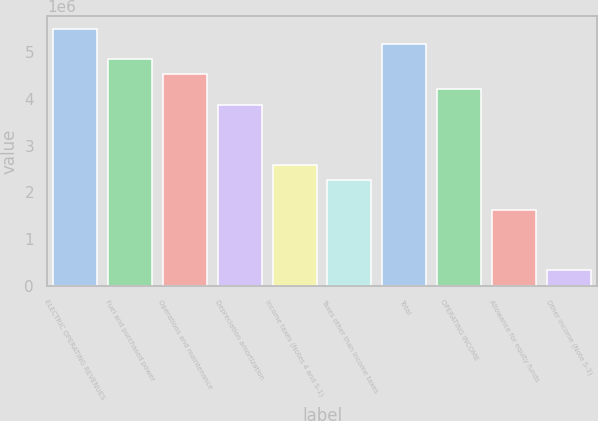<chart> <loc_0><loc_0><loc_500><loc_500><bar_chart><fcel>ELECTRIC OPERATING REVENUES<fcel>Fuel and purchased power<fcel>Operations and maintenance<fcel>Depreciation amortization<fcel>Income taxes (Notes 4 and S-1)<fcel>Taxes other than income taxes<fcel>Total<fcel>OPERATING INCOME<fcel>Allowance for equity funds<fcel>Other income (Note S-3)<nl><fcel>5.50008e+06<fcel>4.85355e+06<fcel>4.53029e+06<fcel>3.88377e+06<fcel>2.59072e+06<fcel>2.26745e+06<fcel>5.17682e+06<fcel>4.20703e+06<fcel>1.62093e+06<fcel>327878<nl></chart> 